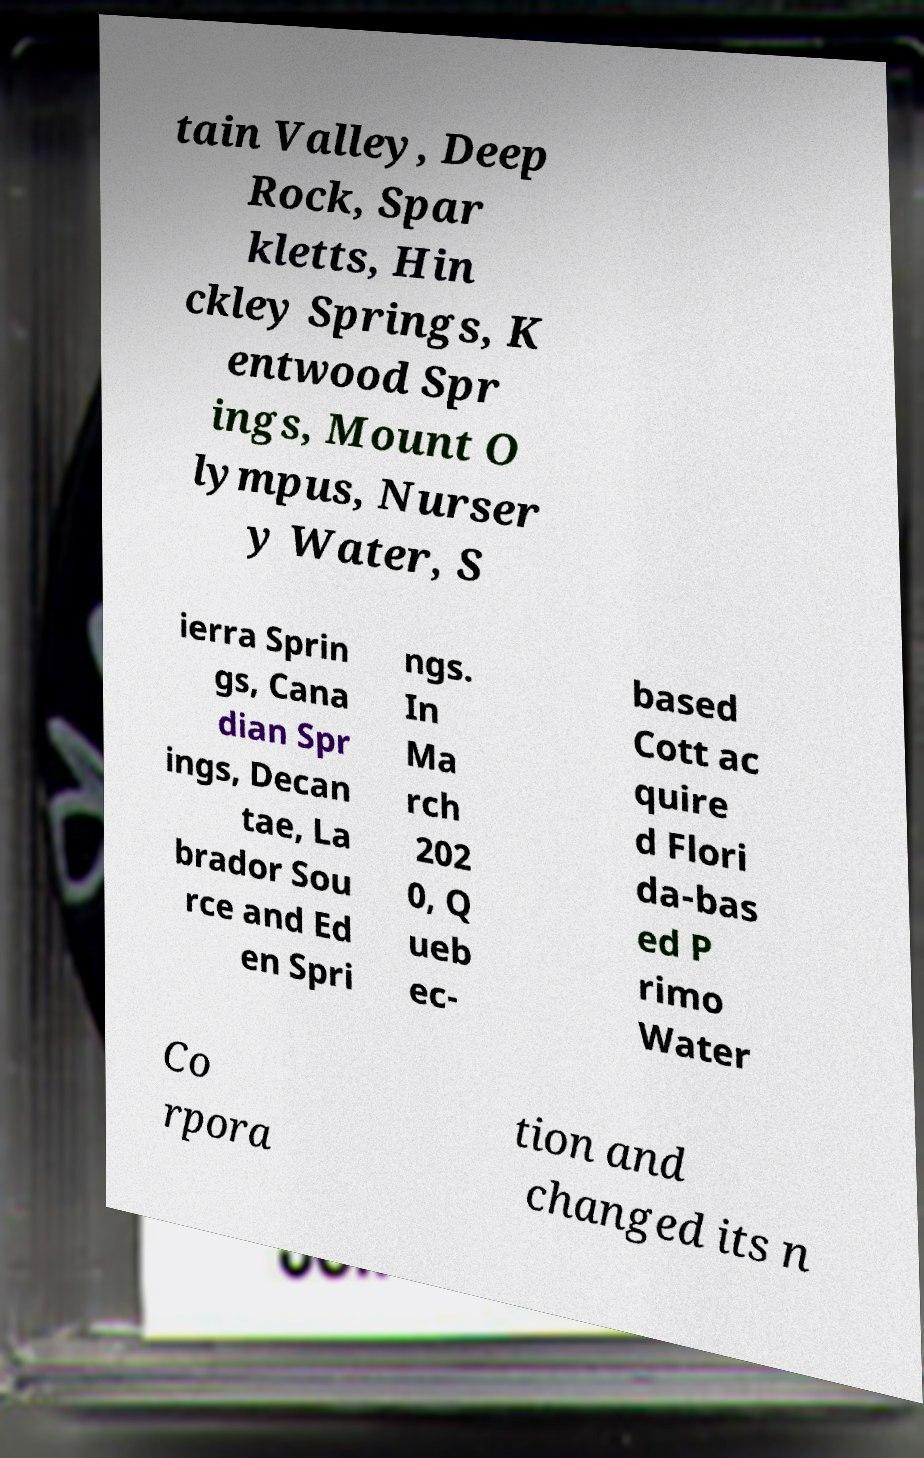Can you accurately transcribe the text from the provided image for me? tain Valley, Deep Rock, Spar kletts, Hin ckley Springs, K entwood Spr ings, Mount O lympus, Nurser y Water, S ierra Sprin gs, Cana dian Spr ings, Decan tae, La brador Sou rce and Ed en Spri ngs. In Ma rch 202 0, Q ueb ec- based Cott ac quire d Flori da-bas ed P rimo Water Co rpora tion and changed its n 